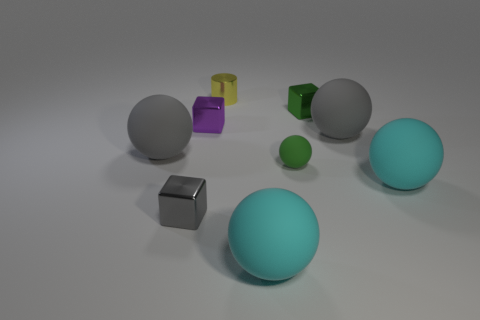Subtract all gray balls. Subtract all blue cubes. How many balls are left? 3 Add 1 big metallic cubes. How many objects exist? 10 Subtract all balls. How many objects are left? 4 Subtract all green matte balls. Subtract all yellow things. How many objects are left? 7 Add 1 small matte spheres. How many small matte spheres are left? 2 Add 5 tiny cyan matte blocks. How many tiny cyan matte blocks exist? 5 Subtract 0 blue cylinders. How many objects are left? 9 